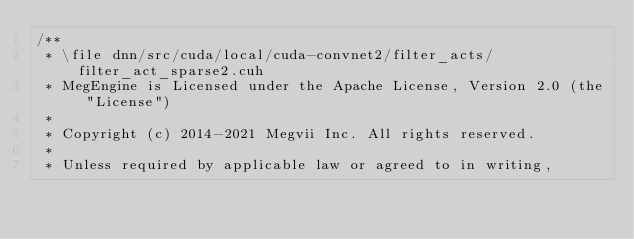Convert code to text. <code><loc_0><loc_0><loc_500><loc_500><_Cuda_>/**
 * \file dnn/src/cuda/local/cuda-convnet2/filter_acts/filter_act_sparse2.cuh
 * MegEngine is Licensed under the Apache License, Version 2.0 (the "License")
 *
 * Copyright (c) 2014-2021 Megvii Inc. All rights reserved.
 *
 * Unless required by applicable law or agreed to in writing,</code> 